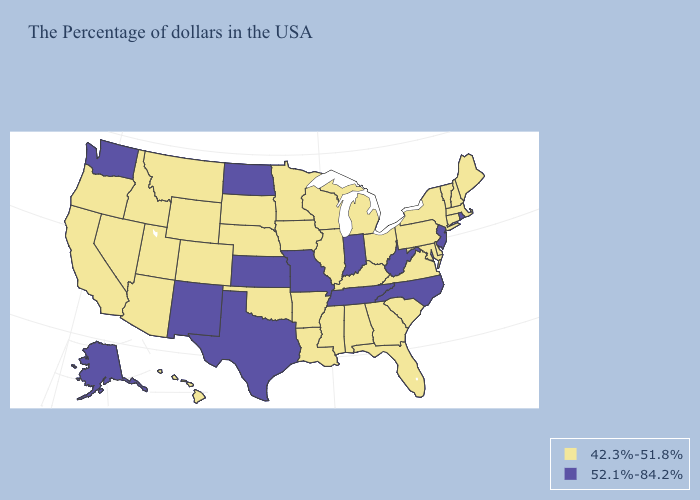Name the states that have a value in the range 52.1%-84.2%?
Short answer required. Rhode Island, New Jersey, North Carolina, West Virginia, Indiana, Tennessee, Missouri, Kansas, Texas, North Dakota, New Mexico, Washington, Alaska. What is the value of North Dakota?
Write a very short answer. 52.1%-84.2%. What is the value of Mississippi?
Concise answer only. 42.3%-51.8%. Name the states that have a value in the range 42.3%-51.8%?
Answer briefly. Maine, Massachusetts, New Hampshire, Vermont, Connecticut, New York, Delaware, Maryland, Pennsylvania, Virginia, South Carolina, Ohio, Florida, Georgia, Michigan, Kentucky, Alabama, Wisconsin, Illinois, Mississippi, Louisiana, Arkansas, Minnesota, Iowa, Nebraska, Oklahoma, South Dakota, Wyoming, Colorado, Utah, Montana, Arizona, Idaho, Nevada, California, Oregon, Hawaii. Which states have the highest value in the USA?
Write a very short answer. Rhode Island, New Jersey, North Carolina, West Virginia, Indiana, Tennessee, Missouri, Kansas, Texas, North Dakota, New Mexico, Washington, Alaska. Name the states that have a value in the range 42.3%-51.8%?
Be succinct. Maine, Massachusetts, New Hampshire, Vermont, Connecticut, New York, Delaware, Maryland, Pennsylvania, Virginia, South Carolina, Ohio, Florida, Georgia, Michigan, Kentucky, Alabama, Wisconsin, Illinois, Mississippi, Louisiana, Arkansas, Minnesota, Iowa, Nebraska, Oklahoma, South Dakota, Wyoming, Colorado, Utah, Montana, Arizona, Idaho, Nevada, California, Oregon, Hawaii. Among the states that border Utah , which have the lowest value?
Answer briefly. Wyoming, Colorado, Arizona, Idaho, Nevada. Does Utah have the lowest value in the West?
Quick response, please. Yes. Does Vermont have the highest value in the Northeast?
Concise answer only. No. What is the highest value in the USA?
Give a very brief answer. 52.1%-84.2%. Does the map have missing data?
Give a very brief answer. No. What is the highest value in states that border Kentucky?
Give a very brief answer. 52.1%-84.2%. What is the highest value in states that border Missouri?
Short answer required. 52.1%-84.2%. 